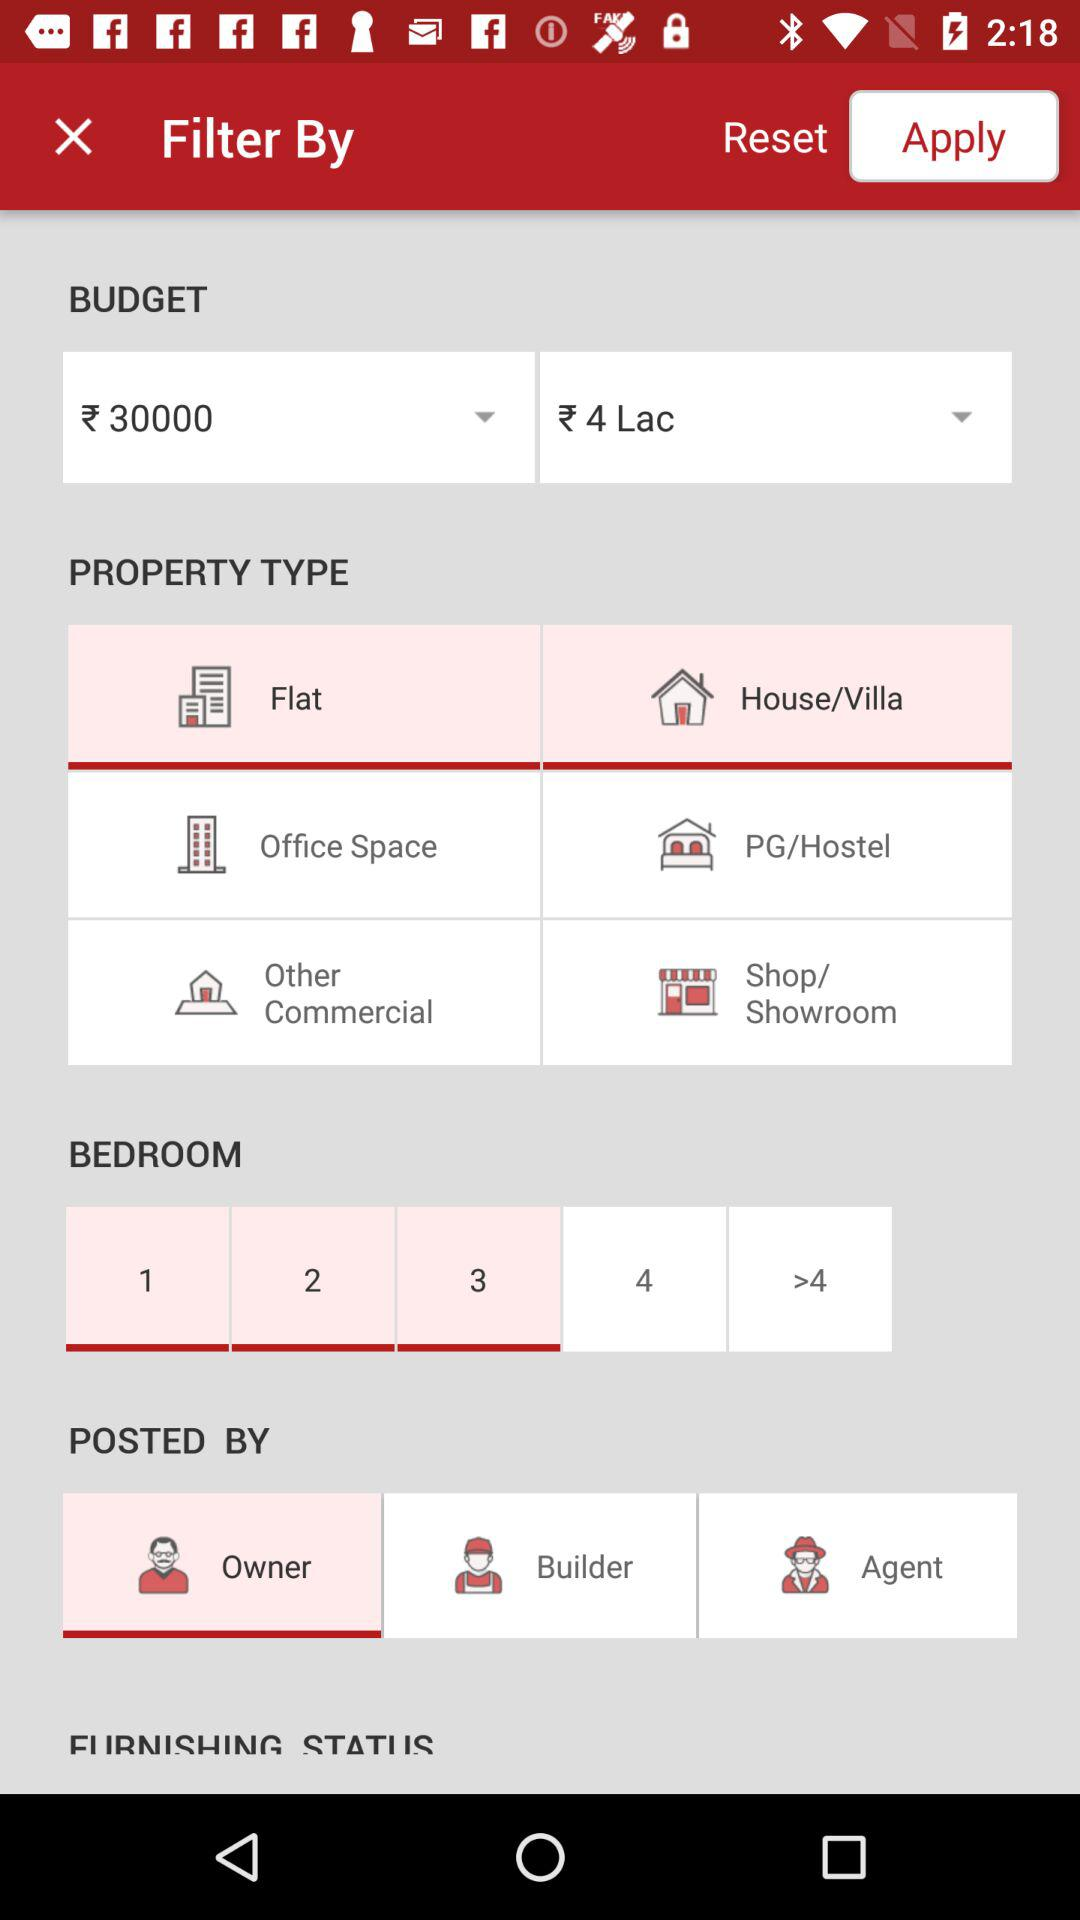Who is posting the requirements? The requirement is being posted by "Owner". 